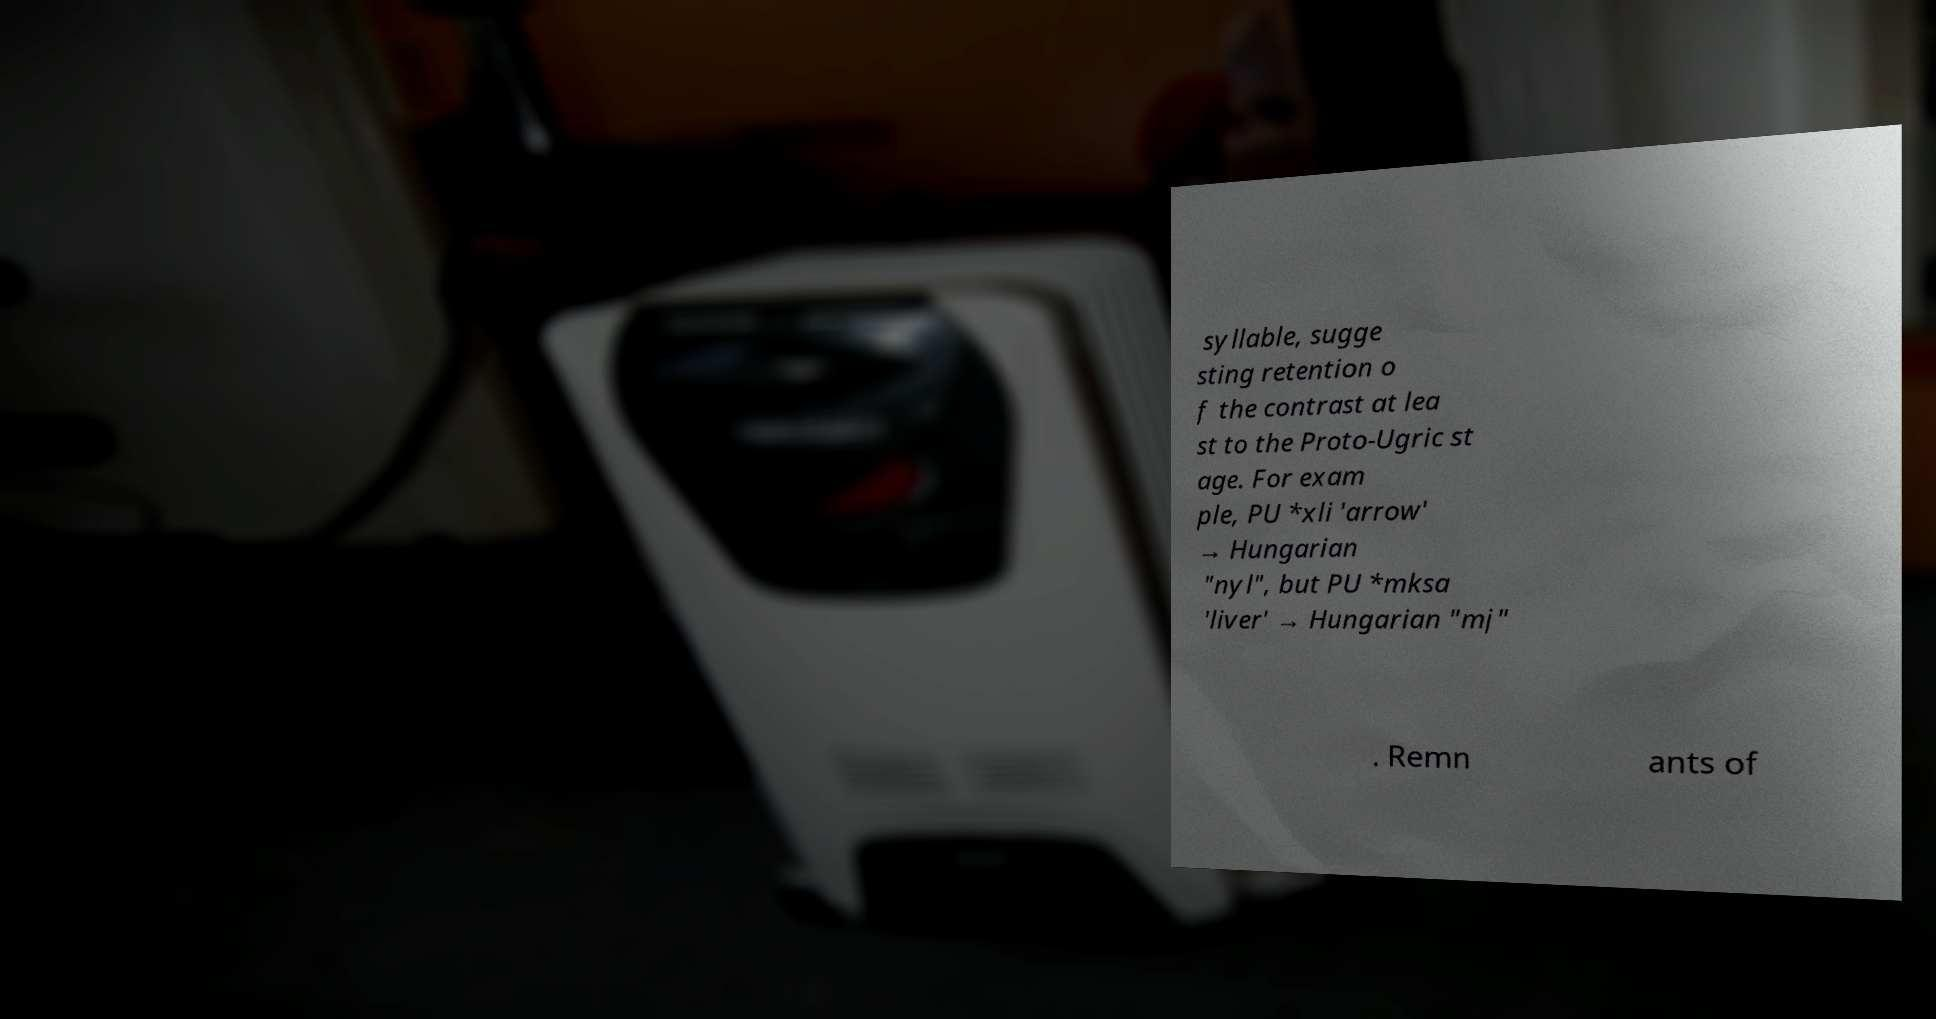Please read and relay the text visible in this image. What does it say? syllable, sugge sting retention o f the contrast at lea st to the Proto-Ugric st age. For exam ple, PU *xli 'arrow' → Hungarian "nyl", but PU *mksa 'liver' → Hungarian "mj" . Remn ants of 